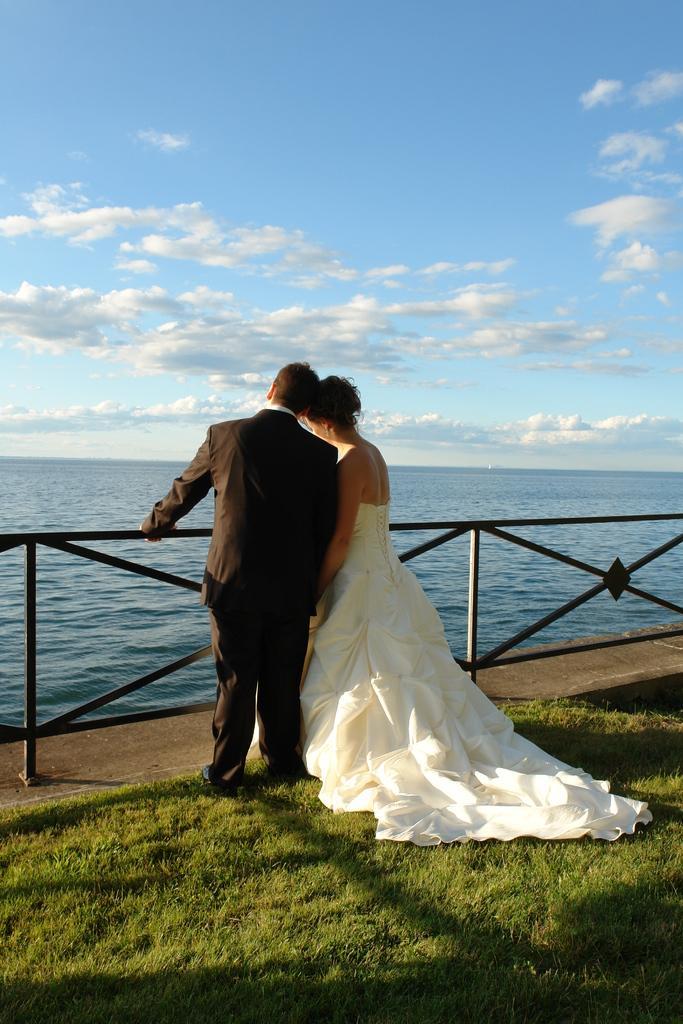Can you describe this image briefly? This picture might be taken from outside of the city and it is sunny. In this image, in the middle, we can see two people man and woman are standing on the grass in front of the metal grill. In the background, we can also see a water in a lake. On the top, we can see a sky, at the bottom there is a grass and a land. 